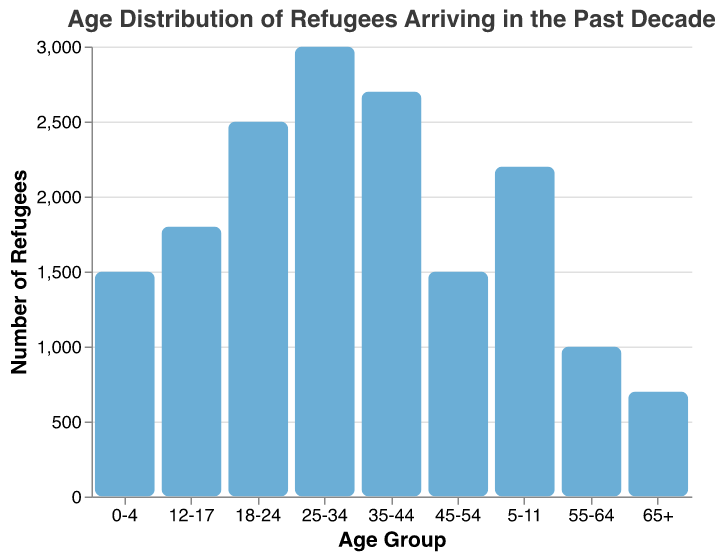Which age group has the most refugees? Find the bar that reaches the highest point along the y-axis, corresponding to "Number of Refugees". The age group with the most refugees is "25-34", represented by the tallest bar.
Answer: 25-34 What is the title of the chart? Look at the text at the top of the figure, which indicates the title. The title is "Age Distribution of Refugees Arriving in the Past Decade".
Answer: Age Distribution of Refugees Arriving in the Past Decade How many refugees are in the "55-64" age group? Locate the bar labeled "55-64" on the x-axis and check its height relative to the y-axis grid lines. The number of refugees in this age group is 1000.
Answer: 1000 What is the total number of refugees for age groups "0-4" and "45-54"? Find the "Number of Refugees" for age groups "0-4" and "45-54" from the bars. Add 1500 (0-4) and 1500 (45-54) to get the total.
Answer: 3000 Which age groups have an equal number of refugees? Identify bars that reach the same height on the y-axis. Both the "0-4" and "45-54" age groups have the same height, indicating they have equal numbers of refugees.
Answer: 0-4 and 45-54 What is the difference in the number of refugees between the "35-44" and "18-24" age groups? Take the numbers associated with the "35-44" (2700) and "18-24" (2500) age groups, then subtract the smaller number from the larger one (2700 - 2500).
Answer: 200 Which age group has the least number of refugees? Find the shortest bar on the chart, which corresponds to the smallest number of refugees. The age group "65+" has the least number of refugees.
Answer: 65+ Are there more refugees in the age group "12-17" or "5-11"? Compare the heights of the bars for "12-17" and "5-11". The bar for "5-11" is taller, indicating more refugees than "12-17".
Answer: 5-11 What is the average number of refugees across all age groups? Sum up the number of refugees for all age groups (1500 + 2200 + 1800 + 2500 + 3000 + 2700 + 1500 + 1000 + 700), which equals 16900. Since there are 9 age groups, divide 16900 by 9. The average is approximately 1877.78.
Answer: ~1878 